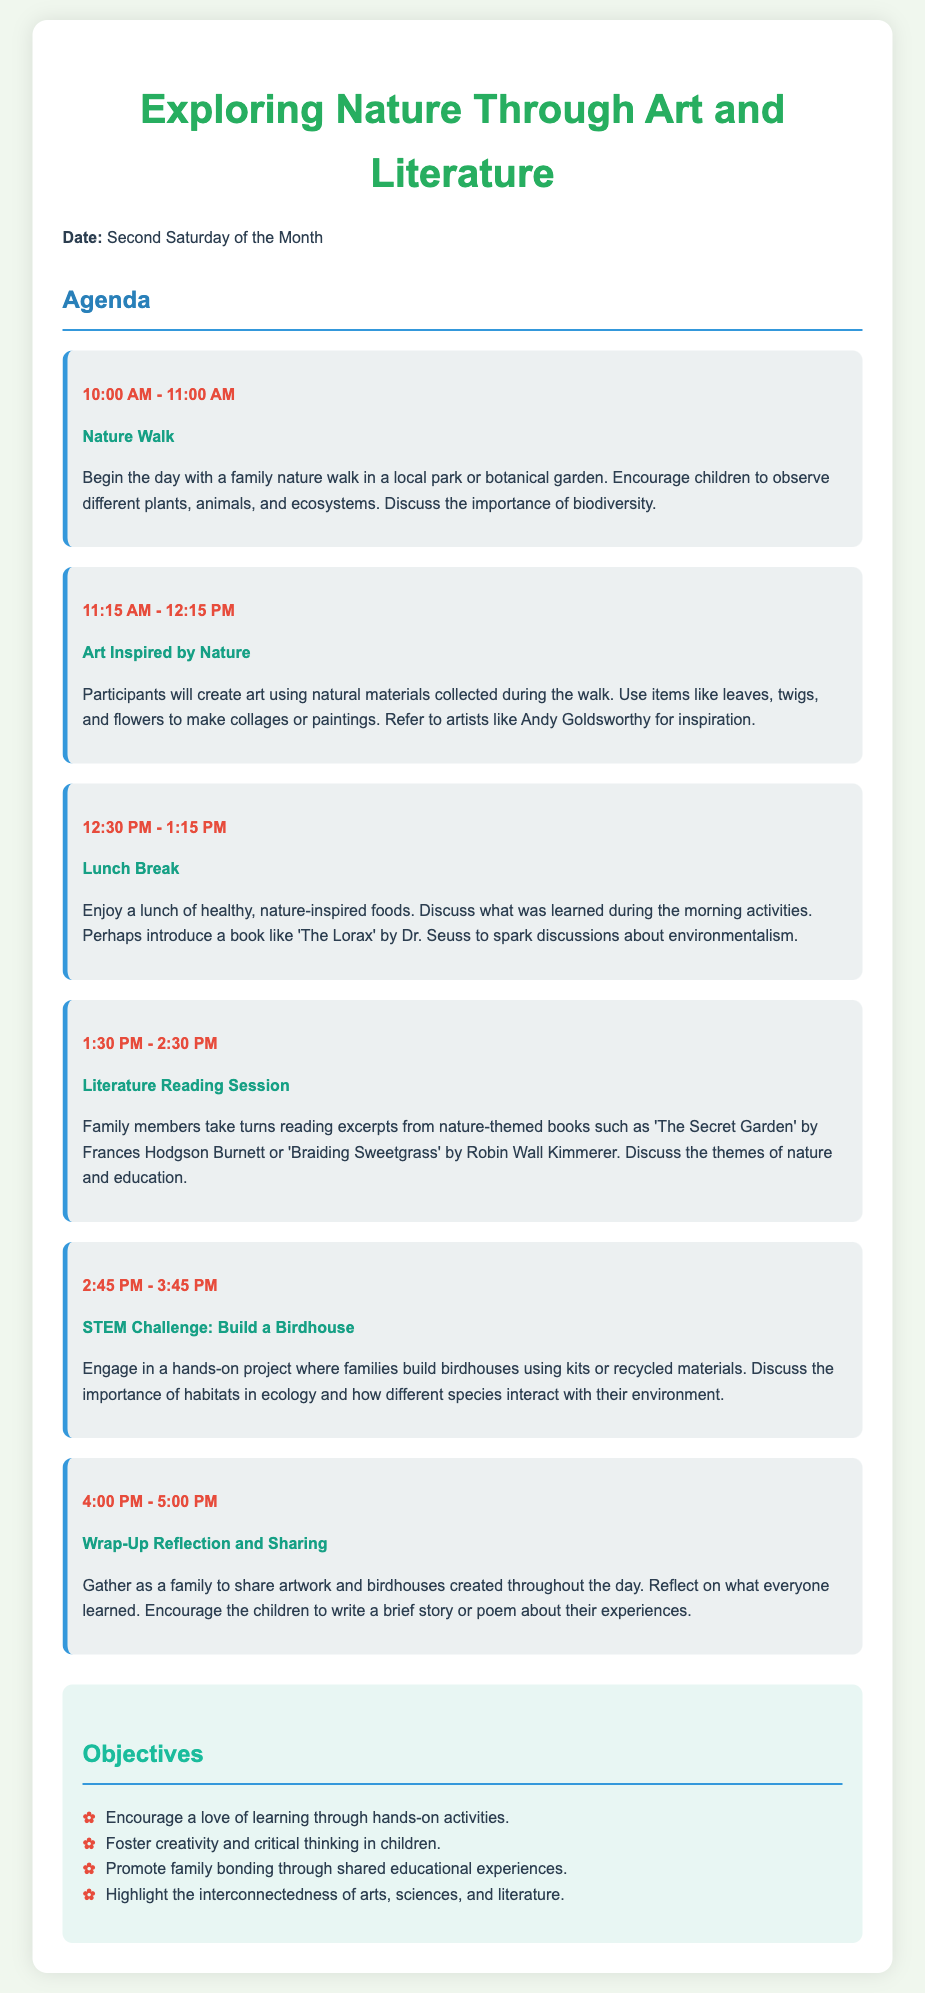what is the theme of the family learning day? The title of the agenda specifies the overall theme, which is about exploring nature through various educational activities.
Answer: Exploring Nature Through Art and Literature when is the family learning day scheduled? The agenda specifies that the event is planned for the second Saturday of the month.
Answer: Second Saturday of the Month what activity follows the lunch break? The agenda lists activities in a specific order, with the activity immediately after lunch being a reading session focused on literature.
Answer: Literature Reading Session how long is the STEM challenge activity? The time allocated for the STEM challenge is explicitly mentioned in the agenda.
Answer: 1 hour which book by Dr. Seuss is mentioned during the lunch break? The agenda references a specific book during the lunch discussion to inspire conversation about environmentalism.
Answer: The Lorax what is one objective of the family learning day? The objectives listed in the document provide several goals for the event, emphasizing the importance of learning through activities.
Answer: Encourage a love of learning through hands-on activities what art form is encouraged during the art activity? The description of the art activity highlights the specific medium to be used during the session.
Answer: Art Inspired by Nature what starts the day's agenda? The first activity laid out in the agenda details the beginning of the event, specifying the nature-related theme.
Answer: Nature Walk 